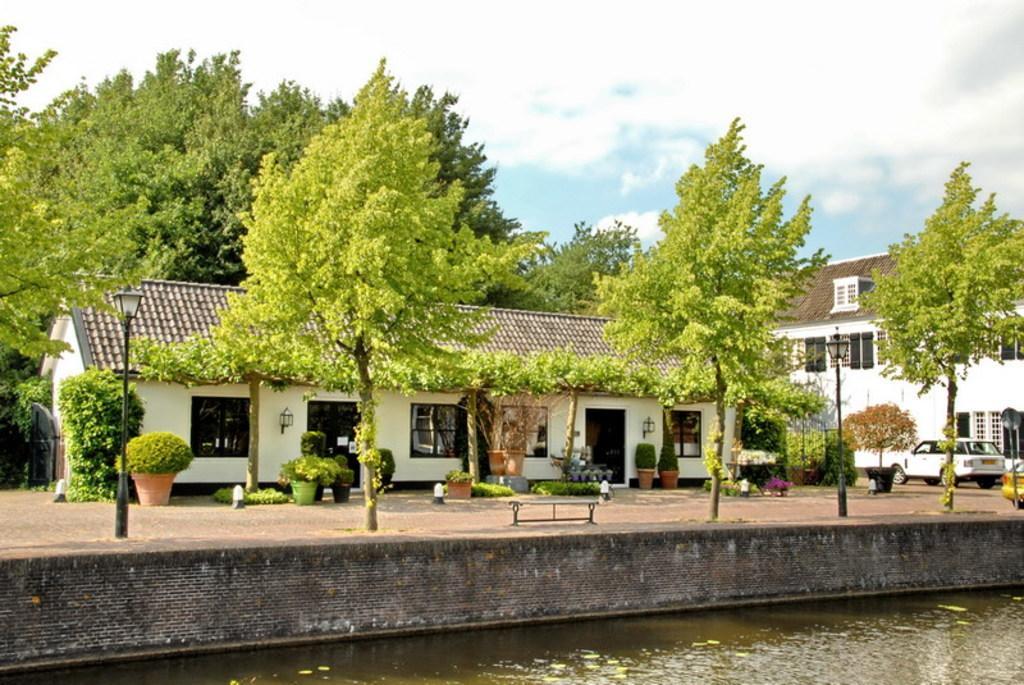In one or two sentences, can you explain what this image depicts? In this image there are houses, around the houses there are trees, in front of the house there are plants, bushes, lamps and benches and there is a car parked, in front of the house there is a lake, at the top of the image there are clouds in the sky. 